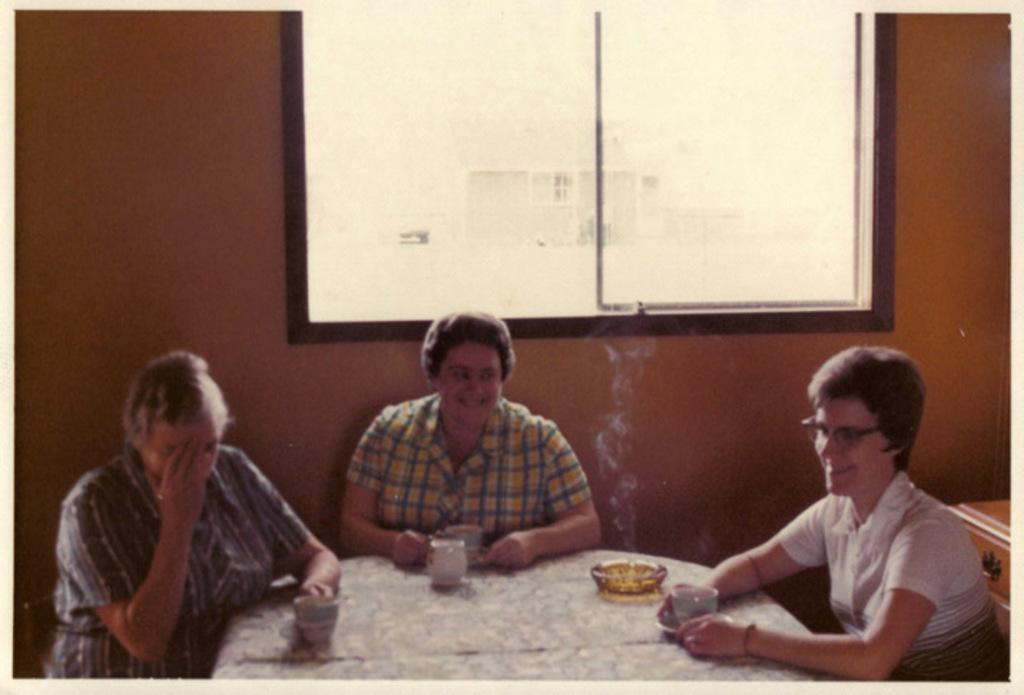How many people are in the image? There are three persons in the image. What are the persons doing in the image? The persons are sitting. What can be seen on the table in the image? There are three glasses on the table. What is visible in the background of the image? There is a bowl, a window, and a wall in the background. Can you tell me how many horses are visible in the image? There are no horses present in the image. What type of geese can be seen walking near the window in the image? There are no geese present in the image, and the window is not shown with any animals walking near it. 